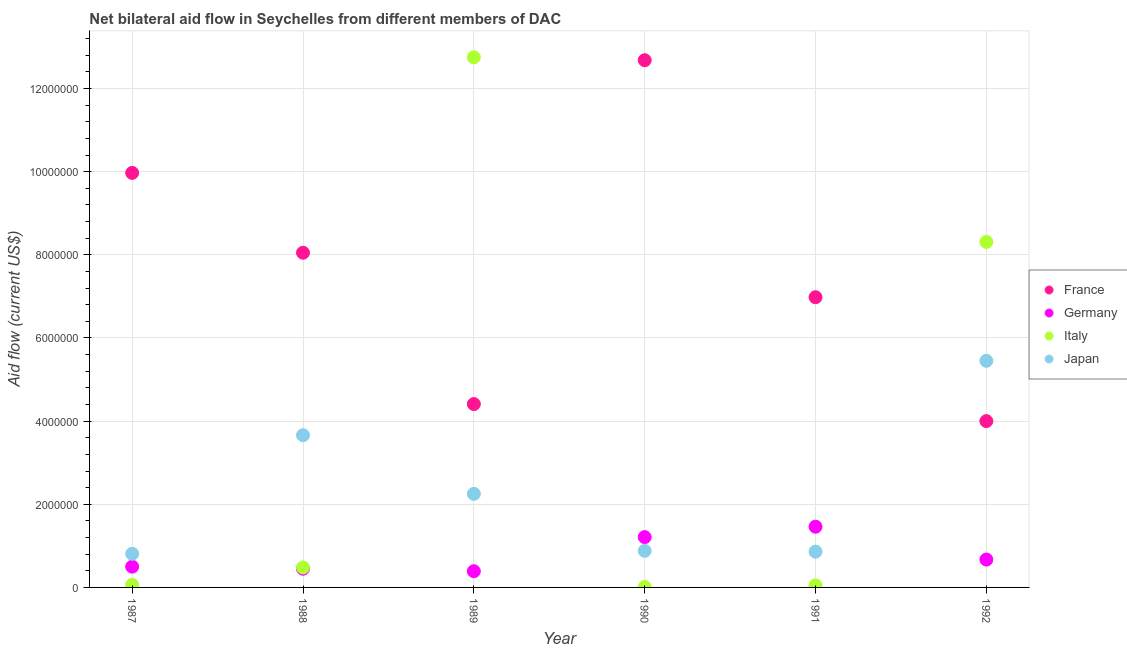What is the amount of aid given by japan in 1987?
Your response must be concise. 8.10e+05. Across all years, what is the maximum amount of aid given by germany?
Your response must be concise. 1.46e+06. Across all years, what is the minimum amount of aid given by france?
Ensure brevity in your answer.  4.00e+06. In which year was the amount of aid given by italy minimum?
Make the answer very short. 1990. What is the total amount of aid given by japan in the graph?
Keep it short and to the point. 1.39e+07. What is the difference between the amount of aid given by germany in 1987 and that in 1992?
Provide a short and direct response. -1.70e+05. What is the difference between the amount of aid given by france in 1989 and the amount of aid given by japan in 1987?
Provide a short and direct response. 3.60e+06. What is the average amount of aid given by germany per year?
Make the answer very short. 7.80e+05. In the year 1989, what is the difference between the amount of aid given by japan and amount of aid given by italy?
Your answer should be very brief. -1.05e+07. What is the ratio of the amount of aid given by germany in 1990 to that in 1992?
Give a very brief answer. 1.81. Is the amount of aid given by italy in 1988 less than that in 1991?
Your response must be concise. No. What is the difference between the highest and the second highest amount of aid given by france?
Keep it short and to the point. 2.71e+06. What is the difference between the highest and the lowest amount of aid given by japan?
Offer a very short reply. 4.64e+06. In how many years, is the amount of aid given by germany greater than the average amount of aid given by germany taken over all years?
Your answer should be very brief. 2. Is it the case that in every year, the sum of the amount of aid given by germany and amount of aid given by italy is greater than the sum of amount of aid given by france and amount of aid given by japan?
Provide a succinct answer. No. Is the amount of aid given by germany strictly greater than the amount of aid given by japan over the years?
Provide a short and direct response. No. Does the graph contain grids?
Give a very brief answer. Yes. How many legend labels are there?
Your answer should be very brief. 4. How are the legend labels stacked?
Your answer should be very brief. Vertical. What is the title of the graph?
Give a very brief answer. Net bilateral aid flow in Seychelles from different members of DAC. What is the label or title of the X-axis?
Make the answer very short. Year. What is the Aid flow (current US$) in France in 1987?
Offer a very short reply. 9.97e+06. What is the Aid flow (current US$) of Japan in 1987?
Keep it short and to the point. 8.10e+05. What is the Aid flow (current US$) in France in 1988?
Your answer should be compact. 8.05e+06. What is the Aid flow (current US$) in Germany in 1988?
Your answer should be very brief. 4.50e+05. What is the Aid flow (current US$) in Italy in 1988?
Provide a succinct answer. 4.80e+05. What is the Aid flow (current US$) of Japan in 1988?
Your answer should be compact. 3.66e+06. What is the Aid flow (current US$) in France in 1989?
Ensure brevity in your answer.  4.41e+06. What is the Aid flow (current US$) of Italy in 1989?
Provide a succinct answer. 1.28e+07. What is the Aid flow (current US$) in Japan in 1989?
Offer a terse response. 2.25e+06. What is the Aid flow (current US$) of France in 1990?
Your response must be concise. 1.27e+07. What is the Aid flow (current US$) in Germany in 1990?
Offer a very short reply. 1.21e+06. What is the Aid flow (current US$) in Italy in 1990?
Offer a very short reply. 10000. What is the Aid flow (current US$) of Japan in 1990?
Your response must be concise. 8.80e+05. What is the Aid flow (current US$) in France in 1991?
Your response must be concise. 6.98e+06. What is the Aid flow (current US$) in Germany in 1991?
Your response must be concise. 1.46e+06. What is the Aid flow (current US$) in Japan in 1991?
Your response must be concise. 8.60e+05. What is the Aid flow (current US$) of France in 1992?
Offer a very short reply. 4.00e+06. What is the Aid flow (current US$) of Germany in 1992?
Offer a very short reply. 6.70e+05. What is the Aid flow (current US$) of Italy in 1992?
Keep it short and to the point. 8.31e+06. What is the Aid flow (current US$) in Japan in 1992?
Provide a succinct answer. 5.45e+06. Across all years, what is the maximum Aid flow (current US$) in France?
Your answer should be compact. 1.27e+07. Across all years, what is the maximum Aid flow (current US$) in Germany?
Keep it short and to the point. 1.46e+06. Across all years, what is the maximum Aid flow (current US$) in Italy?
Offer a very short reply. 1.28e+07. Across all years, what is the maximum Aid flow (current US$) in Japan?
Offer a very short reply. 5.45e+06. Across all years, what is the minimum Aid flow (current US$) in France?
Ensure brevity in your answer.  4.00e+06. Across all years, what is the minimum Aid flow (current US$) of Italy?
Make the answer very short. 10000. Across all years, what is the minimum Aid flow (current US$) in Japan?
Provide a short and direct response. 8.10e+05. What is the total Aid flow (current US$) of France in the graph?
Offer a very short reply. 4.61e+07. What is the total Aid flow (current US$) in Germany in the graph?
Ensure brevity in your answer.  4.68e+06. What is the total Aid flow (current US$) of Italy in the graph?
Keep it short and to the point. 2.17e+07. What is the total Aid flow (current US$) of Japan in the graph?
Provide a short and direct response. 1.39e+07. What is the difference between the Aid flow (current US$) in France in 1987 and that in 1988?
Keep it short and to the point. 1.92e+06. What is the difference between the Aid flow (current US$) of Germany in 1987 and that in 1988?
Provide a succinct answer. 5.00e+04. What is the difference between the Aid flow (current US$) of Italy in 1987 and that in 1988?
Your answer should be very brief. -4.20e+05. What is the difference between the Aid flow (current US$) in Japan in 1987 and that in 1988?
Your response must be concise. -2.85e+06. What is the difference between the Aid flow (current US$) in France in 1987 and that in 1989?
Your answer should be very brief. 5.56e+06. What is the difference between the Aid flow (current US$) in Germany in 1987 and that in 1989?
Offer a very short reply. 1.10e+05. What is the difference between the Aid flow (current US$) in Italy in 1987 and that in 1989?
Provide a succinct answer. -1.27e+07. What is the difference between the Aid flow (current US$) of Japan in 1987 and that in 1989?
Give a very brief answer. -1.44e+06. What is the difference between the Aid flow (current US$) in France in 1987 and that in 1990?
Give a very brief answer. -2.71e+06. What is the difference between the Aid flow (current US$) in Germany in 1987 and that in 1990?
Ensure brevity in your answer.  -7.10e+05. What is the difference between the Aid flow (current US$) of France in 1987 and that in 1991?
Offer a terse response. 2.99e+06. What is the difference between the Aid flow (current US$) of Germany in 1987 and that in 1991?
Make the answer very short. -9.60e+05. What is the difference between the Aid flow (current US$) of Italy in 1987 and that in 1991?
Provide a short and direct response. 10000. What is the difference between the Aid flow (current US$) in France in 1987 and that in 1992?
Provide a succinct answer. 5.97e+06. What is the difference between the Aid flow (current US$) in Germany in 1987 and that in 1992?
Ensure brevity in your answer.  -1.70e+05. What is the difference between the Aid flow (current US$) in Italy in 1987 and that in 1992?
Ensure brevity in your answer.  -8.25e+06. What is the difference between the Aid flow (current US$) of Japan in 1987 and that in 1992?
Give a very brief answer. -4.64e+06. What is the difference between the Aid flow (current US$) of France in 1988 and that in 1989?
Provide a succinct answer. 3.64e+06. What is the difference between the Aid flow (current US$) of Italy in 1988 and that in 1989?
Ensure brevity in your answer.  -1.23e+07. What is the difference between the Aid flow (current US$) of Japan in 1988 and that in 1989?
Offer a terse response. 1.41e+06. What is the difference between the Aid flow (current US$) of France in 1988 and that in 1990?
Your response must be concise. -4.63e+06. What is the difference between the Aid flow (current US$) of Germany in 1988 and that in 1990?
Provide a short and direct response. -7.60e+05. What is the difference between the Aid flow (current US$) in Japan in 1988 and that in 1990?
Your response must be concise. 2.78e+06. What is the difference between the Aid flow (current US$) in France in 1988 and that in 1991?
Provide a succinct answer. 1.07e+06. What is the difference between the Aid flow (current US$) in Germany in 1988 and that in 1991?
Provide a succinct answer. -1.01e+06. What is the difference between the Aid flow (current US$) of Italy in 1988 and that in 1991?
Make the answer very short. 4.30e+05. What is the difference between the Aid flow (current US$) in Japan in 1988 and that in 1991?
Provide a succinct answer. 2.80e+06. What is the difference between the Aid flow (current US$) of France in 1988 and that in 1992?
Provide a short and direct response. 4.05e+06. What is the difference between the Aid flow (current US$) of Germany in 1988 and that in 1992?
Your answer should be very brief. -2.20e+05. What is the difference between the Aid flow (current US$) in Italy in 1988 and that in 1992?
Your answer should be compact. -7.83e+06. What is the difference between the Aid flow (current US$) of Japan in 1988 and that in 1992?
Offer a terse response. -1.79e+06. What is the difference between the Aid flow (current US$) in France in 1989 and that in 1990?
Offer a terse response. -8.27e+06. What is the difference between the Aid flow (current US$) in Germany in 1989 and that in 1990?
Offer a very short reply. -8.20e+05. What is the difference between the Aid flow (current US$) in Italy in 1989 and that in 1990?
Offer a terse response. 1.27e+07. What is the difference between the Aid flow (current US$) of Japan in 1989 and that in 1990?
Your answer should be very brief. 1.37e+06. What is the difference between the Aid flow (current US$) in France in 1989 and that in 1991?
Offer a terse response. -2.57e+06. What is the difference between the Aid flow (current US$) in Germany in 1989 and that in 1991?
Your answer should be very brief. -1.07e+06. What is the difference between the Aid flow (current US$) in Italy in 1989 and that in 1991?
Offer a terse response. 1.27e+07. What is the difference between the Aid flow (current US$) in Japan in 1989 and that in 1991?
Your answer should be compact. 1.39e+06. What is the difference between the Aid flow (current US$) in Germany in 1989 and that in 1992?
Your answer should be very brief. -2.80e+05. What is the difference between the Aid flow (current US$) of Italy in 1989 and that in 1992?
Make the answer very short. 4.44e+06. What is the difference between the Aid flow (current US$) of Japan in 1989 and that in 1992?
Give a very brief answer. -3.20e+06. What is the difference between the Aid flow (current US$) of France in 1990 and that in 1991?
Offer a terse response. 5.70e+06. What is the difference between the Aid flow (current US$) of Germany in 1990 and that in 1991?
Your answer should be very brief. -2.50e+05. What is the difference between the Aid flow (current US$) in Italy in 1990 and that in 1991?
Make the answer very short. -4.00e+04. What is the difference between the Aid flow (current US$) of France in 1990 and that in 1992?
Offer a terse response. 8.68e+06. What is the difference between the Aid flow (current US$) in Germany in 1990 and that in 1992?
Ensure brevity in your answer.  5.40e+05. What is the difference between the Aid flow (current US$) in Italy in 1990 and that in 1992?
Make the answer very short. -8.30e+06. What is the difference between the Aid flow (current US$) in Japan in 1990 and that in 1992?
Your answer should be very brief. -4.57e+06. What is the difference between the Aid flow (current US$) in France in 1991 and that in 1992?
Give a very brief answer. 2.98e+06. What is the difference between the Aid flow (current US$) in Germany in 1991 and that in 1992?
Offer a terse response. 7.90e+05. What is the difference between the Aid flow (current US$) in Italy in 1991 and that in 1992?
Your answer should be compact. -8.26e+06. What is the difference between the Aid flow (current US$) of Japan in 1991 and that in 1992?
Your answer should be compact. -4.59e+06. What is the difference between the Aid flow (current US$) of France in 1987 and the Aid flow (current US$) of Germany in 1988?
Your response must be concise. 9.52e+06. What is the difference between the Aid flow (current US$) in France in 1987 and the Aid flow (current US$) in Italy in 1988?
Make the answer very short. 9.49e+06. What is the difference between the Aid flow (current US$) of France in 1987 and the Aid flow (current US$) of Japan in 1988?
Provide a succinct answer. 6.31e+06. What is the difference between the Aid flow (current US$) of Germany in 1987 and the Aid flow (current US$) of Japan in 1988?
Ensure brevity in your answer.  -3.16e+06. What is the difference between the Aid flow (current US$) of Italy in 1987 and the Aid flow (current US$) of Japan in 1988?
Offer a terse response. -3.60e+06. What is the difference between the Aid flow (current US$) of France in 1987 and the Aid flow (current US$) of Germany in 1989?
Give a very brief answer. 9.58e+06. What is the difference between the Aid flow (current US$) of France in 1987 and the Aid flow (current US$) of Italy in 1989?
Provide a short and direct response. -2.78e+06. What is the difference between the Aid flow (current US$) in France in 1987 and the Aid flow (current US$) in Japan in 1989?
Your answer should be compact. 7.72e+06. What is the difference between the Aid flow (current US$) in Germany in 1987 and the Aid flow (current US$) in Italy in 1989?
Your answer should be very brief. -1.22e+07. What is the difference between the Aid flow (current US$) of Germany in 1987 and the Aid flow (current US$) of Japan in 1989?
Provide a succinct answer. -1.75e+06. What is the difference between the Aid flow (current US$) of Italy in 1987 and the Aid flow (current US$) of Japan in 1989?
Make the answer very short. -2.19e+06. What is the difference between the Aid flow (current US$) of France in 1987 and the Aid flow (current US$) of Germany in 1990?
Your answer should be very brief. 8.76e+06. What is the difference between the Aid flow (current US$) of France in 1987 and the Aid flow (current US$) of Italy in 1990?
Make the answer very short. 9.96e+06. What is the difference between the Aid flow (current US$) in France in 1987 and the Aid flow (current US$) in Japan in 1990?
Your answer should be very brief. 9.09e+06. What is the difference between the Aid flow (current US$) of Germany in 1987 and the Aid flow (current US$) of Italy in 1990?
Ensure brevity in your answer.  4.90e+05. What is the difference between the Aid flow (current US$) of Germany in 1987 and the Aid flow (current US$) of Japan in 1990?
Provide a short and direct response. -3.80e+05. What is the difference between the Aid flow (current US$) in Italy in 1987 and the Aid flow (current US$) in Japan in 1990?
Provide a succinct answer. -8.20e+05. What is the difference between the Aid flow (current US$) of France in 1987 and the Aid flow (current US$) of Germany in 1991?
Offer a very short reply. 8.51e+06. What is the difference between the Aid flow (current US$) in France in 1987 and the Aid flow (current US$) in Italy in 1991?
Provide a succinct answer. 9.92e+06. What is the difference between the Aid flow (current US$) in France in 1987 and the Aid flow (current US$) in Japan in 1991?
Provide a short and direct response. 9.11e+06. What is the difference between the Aid flow (current US$) in Germany in 1987 and the Aid flow (current US$) in Japan in 1991?
Keep it short and to the point. -3.60e+05. What is the difference between the Aid flow (current US$) of Italy in 1987 and the Aid flow (current US$) of Japan in 1991?
Ensure brevity in your answer.  -8.00e+05. What is the difference between the Aid flow (current US$) of France in 1987 and the Aid flow (current US$) of Germany in 1992?
Provide a succinct answer. 9.30e+06. What is the difference between the Aid flow (current US$) in France in 1987 and the Aid flow (current US$) in Italy in 1992?
Offer a very short reply. 1.66e+06. What is the difference between the Aid flow (current US$) in France in 1987 and the Aid flow (current US$) in Japan in 1992?
Your response must be concise. 4.52e+06. What is the difference between the Aid flow (current US$) in Germany in 1987 and the Aid flow (current US$) in Italy in 1992?
Provide a short and direct response. -7.81e+06. What is the difference between the Aid flow (current US$) in Germany in 1987 and the Aid flow (current US$) in Japan in 1992?
Your answer should be compact. -4.95e+06. What is the difference between the Aid flow (current US$) in Italy in 1987 and the Aid flow (current US$) in Japan in 1992?
Provide a short and direct response. -5.39e+06. What is the difference between the Aid flow (current US$) in France in 1988 and the Aid flow (current US$) in Germany in 1989?
Offer a very short reply. 7.66e+06. What is the difference between the Aid flow (current US$) in France in 1988 and the Aid flow (current US$) in Italy in 1989?
Ensure brevity in your answer.  -4.70e+06. What is the difference between the Aid flow (current US$) in France in 1988 and the Aid flow (current US$) in Japan in 1989?
Your response must be concise. 5.80e+06. What is the difference between the Aid flow (current US$) of Germany in 1988 and the Aid flow (current US$) of Italy in 1989?
Offer a terse response. -1.23e+07. What is the difference between the Aid flow (current US$) in Germany in 1988 and the Aid flow (current US$) in Japan in 1989?
Provide a succinct answer. -1.80e+06. What is the difference between the Aid flow (current US$) in Italy in 1988 and the Aid flow (current US$) in Japan in 1989?
Your answer should be compact. -1.77e+06. What is the difference between the Aid flow (current US$) of France in 1988 and the Aid flow (current US$) of Germany in 1990?
Give a very brief answer. 6.84e+06. What is the difference between the Aid flow (current US$) of France in 1988 and the Aid flow (current US$) of Italy in 1990?
Make the answer very short. 8.04e+06. What is the difference between the Aid flow (current US$) in France in 1988 and the Aid flow (current US$) in Japan in 1990?
Ensure brevity in your answer.  7.17e+06. What is the difference between the Aid flow (current US$) of Germany in 1988 and the Aid flow (current US$) of Italy in 1990?
Your answer should be very brief. 4.40e+05. What is the difference between the Aid flow (current US$) of Germany in 1988 and the Aid flow (current US$) of Japan in 1990?
Your response must be concise. -4.30e+05. What is the difference between the Aid flow (current US$) in Italy in 1988 and the Aid flow (current US$) in Japan in 1990?
Offer a very short reply. -4.00e+05. What is the difference between the Aid flow (current US$) of France in 1988 and the Aid flow (current US$) of Germany in 1991?
Ensure brevity in your answer.  6.59e+06. What is the difference between the Aid flow (current US$) of France in 1988 and the Aid flow (current US$) of Italy in 1991?
Provide a succinct answer. 8.00e+06. What is the difference between the Aid flow (current US$) of France in 1988 and the Aid flow (current US$) of Japan in 1991?
Keep it short and to the point. 7.19e+06. What is the difference between the Aid flow (current US$) in Germany in 1988 and the Aid flow (current US$) in Italy in 1991?
Offer a very short reply. 4.00e+05. What is the difference between the Aid flow (current US$) in Germany in 1988 and the Aid flow (current US$) in Japan in 1991?
Provide a short and direct response. -4.10e+05. What is the difference between the Aid flow (current US$) in Italy in 1988 and the Aid flow (current US$) in Japan in 1991?
Your answer should be very brief. -3.80e+05. What is the difference between the Aid flow (current US$) of France in 1988 and the Aid flow (current US$) of Germany in 1992?
Offer a very short reply. 7.38e+06. What is the difference between the Aid flow (current US$) in France in 1988 and the Aid flow (current US$) in Italy in 1992?
Provide a succinct answer. -2.60e+05. What is the difference between the Aid flow (current US$) in France in 1988 and the Aid flow (current US$) in Japan in 1992?
Provide a succinct answer. 2.60e+06. What is the difference between the Aid flow (current US$) of Germany in 1988 and the Aid flow (current US$) of Italy in 1992?
Your answer should be compact. -7.86e+06. What is the difference between the Aid flow (current US$) in Germany in 1988 and the Aid flow (current US$) in Japan in 1992?
Offer a terse response. -5.00e+06. What is the difference between the Aid flow (current US$) of Italy in 1988 and the Aid flow (current US$) of Japan in 1992?
Ensure brevity in your answer.  -4.97e+06. What is the difference between the Aid flow (current US$) in France in 1989 and the Aid flow (current US$) in Germany in 1990?
Offer a very short reply. 3.20e+06. What is the difference between the Aid flow (current US$) in France in 1989 and the Aid flow (current US$) in Italy in 1990?
Provide a short and direct response. 4.40e+06. What is the difference between the Aid flow (current US$) in France in 1989 and the Aid flow (current US$) in Japan in 1990?
Provide a short and direct response. 3.53e+06. What is the difference between the Aid flow (current US$) of Germany in 1989 and the Aid flow (current US$) of Italy in 1990?
Offer a very short reply. 3.80e+05. What is the difference between the Aid flow (current US$) of Germany in 1989 and the Aid flow (current US$) of Japan in 1990?
Your answer should be compact. -4.90e+05. What is the difference between the Aid flow (current US$) in Italy in 1989 and the Aid flow (current US$) in Japan in 1990?
Offer a very short reply. 1.19e+07. What is the difference between the Aid flow (current US$) in France in 1989 and the Aid flow (current US$) in Germany in 1991?
Your response must be concise. 2.95e+06. What is the difference between the Aid flow (current US$) in France in 1989 and the Aid flow (current US$) in Italy in 1991?
Keep it short and to the point. 4.36e+06. What is the difference between the Aid flow (current US$) in France in 1989 and the Aid flow (current US$) in Japan in 1991?
Keep it short and to the point. 3.55e+06. What is the difference between the Aid flow (current US$) in Germany in 1989 and the Aid flow (current US$) in Italy in 1991?
Your answer should be very brief. 3.40e+05. What is the difference between the Aid flow (current US$) of Germany in 1989 and the Aid flow (current US$) of Japan in 1991?
Give a very brief answer. -4.70e+05. What is the difference between the Aid flow (current US$) of Italy in 1989 and the Aid flow (current US$) of Japan in 1991?
Your answer should be compact. 1.19e+07. What is the difference between the Aid flow (current US$) of France in 1989 and the Aid flow (current US$) of Germany in 1992?
Your answer should be compact. 3.74e+06. What is the difference between the Aid flow (current US$) of France in 1989 and the Aid flow (current US$) of Italy in 1992?
Provide a short and direct response. -3.90e+06. What is the difference between the Aid flow (current US$) of France in 1989 and the Aid flow (current US$) of Japan in 1992?
Your answer should be compact. -1.04e+06. What is the difference between the Aid flow (current US$) of Germany in 1989 and the Aid flow (current US$) of Italy in 1992?
Offer a terse response. -7.92e+06. What is the difference between the Aid flow (current US$) of Germany in 1989 and the Aid flow (current US$) of Japan in 1992?
Give a very brief answer. -5.06e+06. What is the difference between the Aid flow (current US$) of Italy in 1989 and the Aid flow (current US$) of Japan in 1992?
Provide a short and direct response. 7.30e+06. What is the difference between the Aid flow (current US$) of France in 1990 and the Aid flow (current US$) of Germany in 1991?
Offer a very short reply. 1.12e+07. What is the difference between the Aid flow (current US$) in France in 1990 and the Aid flow (current US$) in Italy in 1991?
Make the answer very short. 1.26e+07. What is the difference between the Aid flow (current US$) of France in 1990 and the Aid flow (current US$) of Japan in 1991?
Ensure brevity in your answer.  1.18e+07. What is the difference between the Aid flow (current US$) in Germany in 1990 and the Aid flow (current US$) in Italy in 1991?
Give a very brief answer. 1.16e+06. What is the difference between the Aid flow (current US$) in Germany in 1990 and the Aid flow (current US$) in Japan in 1991?
Offer a very short reply. 3.50e+05. What is the difference between the Aid flow (current US$) in Italy in 1990 and the Aid flow (current US$) in Japan in 1991?
Provide a succinct answer. -8.50e+05. What is the difference between the Aid flow (current US$) in France in 1990 and the Aid flow (current US$) in Germany in 1992?
Your answer should be very brief. 1.20e+07. What is the difference between the Aid flow (current US$) in France in 1990 and the Aid flow (current US$) in Italy in 1992?
Your answer should be very brief. 4.37e+06. What is the difference between the Aid flow (current US$) in France in 1990 and the Aid flow (current US$) in Japan in 1992?
Keep it short and to the point. 7.23e+06. What is the difference between the Aid flow (current US$) in Germany in 1990 and the Aid flow (current US$) in Italy in 1992?
Give a very brief answer. -7.10e+06. What is the difference between the Aid flow (current US$) of Germany in 1990 and the Aid flow (current US$) of Japan in 1992?
Ensure brevity in your answer.  -4.24e+06. What is the difference between the Aid flow (current US$) in Italy in 1990 and the Aid flow (current US$) in Japan in 1992?
Your response must be concise. -5.44e+06. What is the difference between the Aid flow (current US$) in France in 1991 and the Aid flow (current US$) in Germany in 1992?
Provide a succinct answer. 6.31e+06. What is the difference between the Aid flow (current US$) of France in 1991 and the Aid flow (current US$) of Italy in 1992?
Give a very brief answer. -1.33e+06. What is the difference between the Aid flow (current US$) of France in 1991 and the Aid flow (current US$) of Japan in 1992?
Your answer should be compact. 1.53e+06. What is the difference between the Aid flow (current US$) of Germany in 1991 and the Aid flow (current US$) of Italy in 1992?
Ensure brevity in your answer.  -6.85e+06. What is the difference between the Aid flow (current US$) in Germany in 1991 and the Aid flow (current US$) in Japan in 1992?
Ensure brevity in your answer.  -3.99e+06. What is the difference between the Aid flow (current US$) in Italy in 1991 and the Aid flow (current US$) in Japan in 1992?
Provide a short and direct response. -5.40e+06. What is the average Aid flow (current US$) in France per year?
Give a very brief answer. 7.68e+06. What is the average Aid flow (current US$) in Germany per year?
Make the answer very short. 7.80e+05. What is the average Aid flow (current US$) in Italy per year?
Offer a terse response. 3.61e+06. What is the average Aid flow (current US$) of Japan per year?
Provide a succinct answer. 2.32e+06. In the year 1987, what is the difference between the Aid flow (current US$) of France and Aid flow (current US$) of Germany?
Offer a very short reply. 9.47e+06. In the year 1987, what is the difference between the Aid flow (current US$) of France and Aid flow (current US$) of Italy?
Your answer should be compact. 9.91e+06. In the year 1987, what is the difference between the Aid flow (current US$) of France and Aid flow (current US$) of Japan?
Your response must be concise. 9.16e+06. In the year 1987, what is the difference between the Aid flow (current US$) in Germany and Aid flow (current US$) in Italy?
Your answer should be compact. 4.40e+05. In the year 1987, what is the difference between the Aid flow (current US$) in Germany and Aid flow (current US$) in Japan?
Offer a terse response. -3.10e+05. In the year 1987, what is the difference between the Aid flow (current US$) in Italy and Aid flow (current US$) in Japan?
Your answer should be very brief. -7.50e+05. In the year 1988, what is the difference between the Aid flow (current US$) of France and Aid flow (current US$) of Germany?
Provide a succinct answer. 7.60e+06. In the year 1988, what is the difference between the Aid flow (current US$) of France and Aid flow (current US$) of Italy?
Offer a very short reply. 7.57e+06. In the year 1988, what is the difference between the Aid flow (current US$) in France and Aid flow (current US$) in Japan?
Your answer should be compact. 4.39e+06. In the year 1988, what is the difference between the Aid flow (current US$) in Germany and Aid flow (current US$) in Japan?
Make the answer very short. -3.21e+06. In the year 1988, what is the difference between the Aid flow (current US$) of Italy and Aid flow (current US$) of Japan?
Give a very brief answer. -3.18e+06. In the year 1989, what is the difference between the Aid flow (current US$) of France and Aid flow (current US$) of Germany?
Ensure brevity in your answer.  4.02e+06. In the year 1989, what is the difference between the Aid flow (current US$) in France and Aid flow (current US$) in Italy?
Offer a terse response. -8.34e+06. In the year 1989, what is the difference between the Aid flow (current US$) in France and Aid flow (current US$) in Japan?
Provide a short and direct response. 2.16e+06. In the year 1989, what is the difference between the Aid flow (current US$) in Germany and Aid flow (current US$) in Italy?
Your response must be concise. -1.24e+07. In the year 1989, what is the difference between the Aid flow (current US$) of Germany and Aid flow (current US$) of Japan?
Your answer should be very brief. -1.86e+06. In the year 1989, what is the difference between the Aid flow (current US$) of Italy and Aid flow (current US$) of Japan?
Give a very brief answer. 1.05e+07. In the year 1990, what is the difference between the Aid flow (current US$) in France and Aid flow (current US$) in Germany?
Keep it short and to the point. 1.15e+07. In the year 1990, what is the difference between the Aid flow (current US$) of France and Aid flow (current US$) of Italy?
Make the answer very short. 1.27e+07. In the year 1990, what is the difference between the Aid flow (current US$) of France and Aid flow (current US$) of Japan?
Your answer should be compact. 1.18e+07. In the year 1990, what is the difference between the Aid flow (current US$) of Germany and Aid flow (current US$) of Italy?
Ensure brevity in your answer.  1.20e+06. In the year 1990, what is the difference between the Aid flow (current US$) of Italy and Aid flow (current US$) of Japan?
Provide a short and direct response. -8.70e+05. In the year 1991, what is the difference between the Aid flow (current US$) in France and Aid flow (current US$) in Germany?
Make the answer very short. 5.52e+06. In the year 1991, what is the difference between the Aid flow (current US$) of France and Aid flow (current US$) of Italy?
Offer a very short reply. 6.93e+06. In the year 1991, what is the difference between the Aid flow (current US$) of France and Aid flow (current US$) of Japan?
Your response must be concise. 6.12e+06. In the year 1991, what is the difference between the Aid flow (current US$) of Germany and Aid flow (current US$) of Italy?
Your response must be concise. 1.41e+06. In the year 1991, what is the difference between the Aid flow (current US$) of Italy and Aid flow (current US$) of Japan?
Your answer should be compact. -8.10e+05. In the year 1992, what is the difference between the Aid flow (current US$) in France and Aid flow (current US$) in Germany?
Provide a short and direct response. 3.33e+06. In the year 1992, what is the difference between the Aid flow (current US$) of France and Aid flow (current US$) of Italy?
Ensure brevity in your answer.  -4.31e+06. In the year 1992, what is the difference between the Aid flow (current US$) in France and Aid flow (current US$) in Japan?
Your answer should be compact. -1.45e+06. In the year 1992, what is the difference between the Aid flow (current US$) of Germany and Aid flow (current US$) of Italy?
Keep it short and to the point. -7.64e+06. In the year 1992, what is the difference between the Aid flow (current US$) in Germany and Aid flow (current US$) in Japan?
Make the answer very short. -4.78e+06. In the year 1992, what is the difference between the Aid flow (current US$) of Italy and Aid flow (current US$) of Japan?
Offer a very short reply. 2.86e+06. What is the ratio of the Aid flow (current US$) in France in 1987 to that in 1988?
Keep it short and to the point. 1.24. What is the ratio of the Aid flow (current US$) of Italy in 1987 to that in 1988?
Give a very brief answer. 0.12. What is the ratio of the Aid flow (current US$) in Japan in 1987 to that in 1988?
Provide a short and direct response. 0.22. What is the ratio of the Aid flow (current US$) in France in 1987 to that in 1989?
Give a very brief answer. 2.26. What is the ratio of the Aid flow (current US$) of Germany in 1987 to that in 1989?
Ensure brevity in your answer.  1.28. What is the ratio of the Aid flow (current US$) in Italy in 1987 to that in 1989?
Provide a succinct answer. 0. What is the ratio of the Aid flow (current US$) in Japan in 1987 to that in 1989?
Provide a short and direct response. 0.36. What is the ratio of the Aid flow (current US$) in France in 1987 to that in 1990?
Provide a succinct answer. 0.79. What is the ratio of the Aid flow (current US$) in Germany in 1987 to that in 1990?
Offer a terse response. 0.41. What is the ratio of the Aid flow (current US$) in Italy in 1987 to that in 1990?
Provide a short and direct response. 6. What is the ratio of the Aid flow (current US$) of Japan in 1987 to that in 1990?
Your answer should be very brief. 0.92. What is the ratio of the Aid flow (current US$) in France in 1987 to that in 1991?
Offer a very short reply. 1.43. What is the ratio of the Aid flow (current US$) in Germany in 1987 to that in 1991?
Your answer should be compact. 0.34. What is the ratio of the Aid flow (current US$) in Italy in 1987 to that in 1991?
Keep it short and to the point. 1.2. What is the ratio of the Aid flow (current US$) in Japan in 1987 to that in 1991?
Offer a very short reply. 0.94. What is the ratio of the Aid flow (current US$) in France in 1987 to that in 1992?
Make the answer very short. 2.49. What is the ratio of the Aid flow (current US$) of Germany in 1987 to that in 1992?
Keep it short and to the point. 0.75. What is the ratio of the Aid flow (current US$) of Italy in 1987 to that in 1992?
Your response must be concise. 0.01. What is the ratio of the Aid flow (current US$) of Japan in 1987 to that in 1992?
Provide a succinct answer. 0.15. What is the ratio of the Aid flow (current US$) of France in 1988 to that in 1989?
Your answer should be very brief. 1.83. What is the ratio of the Aid flow (current US$) in Germany in 1988 to that in 1989?
Make the answer very short. 1.15. What is the ratio of the Aid flow (current US$) in Italy in 1988 to that in 1989?
Provide a succinct answer. 0.04. What is the ratio of the Aid flow (current US$) in Japan in 1988 to that in 1989?
Ensure brevity in your answer.  1.63. What is the ratio of the Aid flow (current US$) in France in 1988 to that in 1990?
Offer a very short reply. 0.63. What is the ratio of the Aid flow (current US$) in Germany in 1988 to that in 1990?
Provide a short and direct response. 0.37. What is the ratio of the Aid flow (current US$) of Italy in 1988 to that in 1990?
Provide a succinct answer. 48. What is the ratio of the Aid flow (current US$) of Japan in 1988 to that in 1990?
Offer a very short reply. 4.16. What is the ratio of the Aid flow (current US$) in France in 1988 to that in 1991?
Provide a short and direct response. 1.15. What is the ratio of the Aid flow (current US$) of Germany in 1988 to that in 1991?
Your answer should be compact. 0.31. What is the ratio of the Aid flow (current US$) of Italy in 1988 to that in 1991?
Ensure brevity in your answer.  9.6. What is the ratio of the Aid flow (current US$) in Japan in 1988 to that in 1991?
Your answer should be compact. 4.26. What is the ratio of the Aid flow (current US$) in France in 1988 to that in 1992?
Your response must be concise. 2.01. What is the ratio of the Aid flow (current US$) of Germany in 1988 to that in 1992?
Give a very brief answer. 0.67. What is the ratio of the Aid flow (current US$) of Italy in 1988 to that in 1992?
Offer a very short reply. 0.06. What is the ratio of the Aid flow (current US$) of Japan in 1988 to that in 1992?
Your answer should be very brief. 0.67. What is the ratio of the Aid flow (current US$) in France in 1989 to that in 1990?
Keep it short and to the point. 0.35. What is the ratio of the Aid flow (current US$) of Germany in 1989 to that in 1990?
Offer a terse response. 0.32. What is the ratio of the Aid flow (current US$) in Italy in 1989 to that in 1990?
Ensure brevity in your answer.  1275. What is the ratio of the Aid flow (current US$) in Japan in 1989 to that in 1990?
Offer a terse response. 2.56. What is the ratio of the Aid flow (current US$) in France in 1989 to that in 1991?
Your answer should be very brief. 0.63. What is the ratio of the Aid flow (current US$) in Germany in 1989 to that in 1991?
Ensure brevity in your answer.  0.27. What is the ratio of the Aid flow (current US$) in Italy in 1989 to that in 1991?
Your response must be concise. 255. What is the ratio of the Aid flow (current US$) of Japan in 1989 to that in 1991?
Give a very brief answer. 2.62. What is the ratio of the Aid flow (current US$) in France in 1989 to that in 1992?
Provide a short and direct response. 1.1. What is the ratio of the Aid flow (current US$) in Germany in 1989 to that in 1992?
Offer a very short reply. 0.58. What is the ratio of the Aid flow (current US$) of Italy in 1989 to that in 1992?
Keep it short and to the point. 1.53. What is the ratio of the Aid flow (current US$) of Japan in 1989 to that in 1992?
Provide a short and direct response. 0.41. What is the ratio of the Aid flow (current US$) of France in 1990 to that in 1991?
Offer a very short reply. 1.82. What is the ratio of the Aid flow (current US$) in Germany in 1990 to that in 1991?
Your answer should be compact. 0.83. What is the ratio of the Aid flow (current US$) of Japan in 1990 to that in 1991?
Provide a succinct answer. 1.02. What is the ratio of the Aid flow (current US$) of France in 1990 to that in 1992?
Your answer should be compact. 3.17. What is the ratio of the Aid flow (current US$) of Germany in 1990 to that in 1992?
Your answer should be very brief. 1.81. What is the ratio of the Aid flow (current US$) in Italy in 1990 to that in 1992?
Provide a short and direct response. 0. What is the ratio of the Aid flow (current US$) in Japan in 1990 to that in 1992?
Offer a very short reply. 0.16. What is the ratio of the Aid flow (current US$) in France in 1991 to that in 1992?
Your answer should be very brief. 1.75. What is the ratio of the Aid flow (current US$) of Germany in 1991 to that in 1992?
Offer a terse response. 2.18. What is the ratio of the Aid flow (current US$) in Italy in 1991 to that in 1992?
Provide a succinct answer. 0.01. What is the ratio of the Aid flow (current US$) of Japan in 1991 to that in 1992?
Offer a terse response. 0.16. What is the difference between the highest and the second highest Aid flow (current US$) of France?
Your answer should be compact. 2.71e+06. What is the difference between the highest and the second highest Aid flow (current US$) in Italy?
Offer a very short reply. 4.44e+06. What is the difference between the highest and the second highest Aid flow (current US$) of Japan?
Offer a terse response. 1.79e+06. What is the difference between the highest and the lowest Aid flow (current US$) of France?
Your answer should be compact. 8.68e+06. What is the difference between the highest and the lowest Aid flow (current US$) in Germany?
Ensure brevity in your answer.  1.07e+06. What is the difference between the highest and the lowest Aid flow (current US$) of Italy?
Make the answer very short. 1.27e+07. What is the difference between the highest and the lowest Aid flow (current US$) of Japan?
Ensure brevity in your answer.  4.64e+06. 